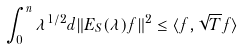Convert formula to latex. <formula><loc_0><loc_0><loc_500><loc_500>\int _ { 0 } ^ { n } \lambda ^ { 1 / 2 } d \| E _ { S } ( \lambda ) f \| ^ { 2 } \leq \langle f , \sqrt { T } f \rangle</formula> 